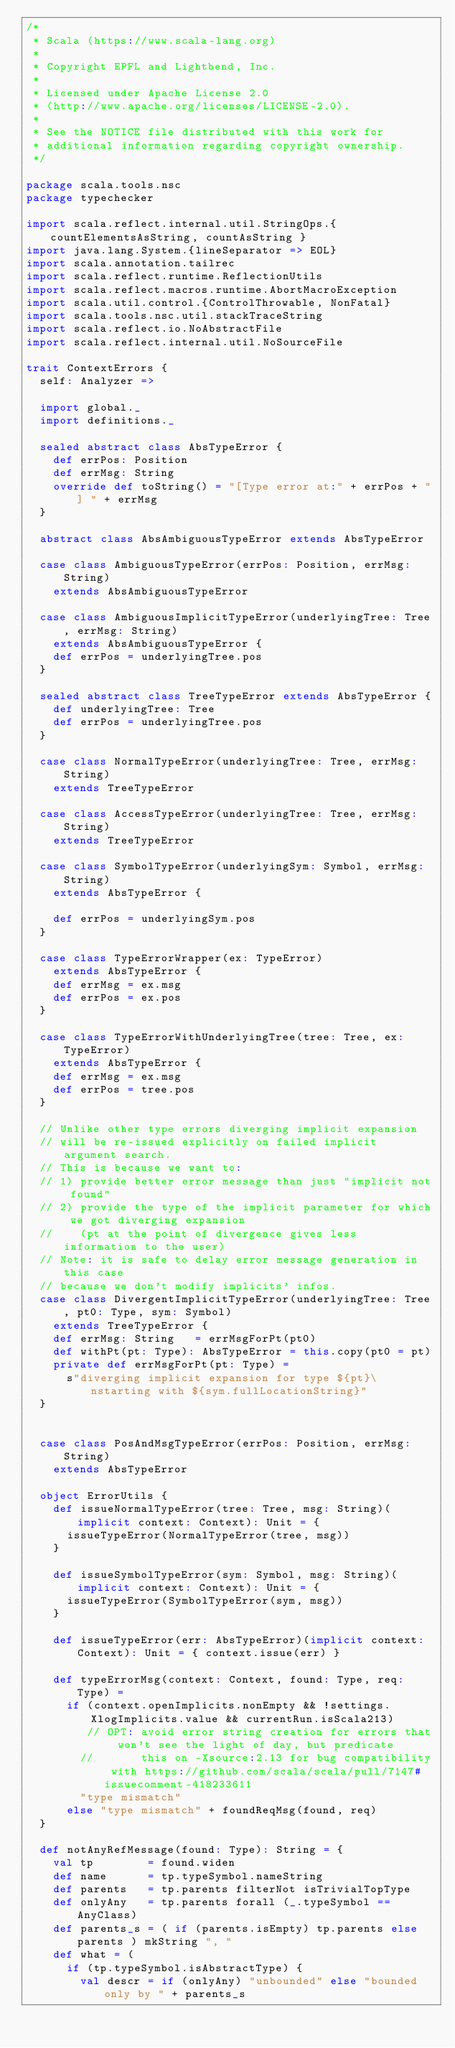<code> <loc_0><loc_0><loc_500><loc_500><_Scala_>/*
 * Scala (https://www.scala-lang.org)
 *
 * Copyright EPFL and Lightbend, Inc.
 *
 * Licensed under Apache License 2.0
 * (http://www.apache.org/licenses/LICENSE-2.0).
 *
 * See the NOTICE file distributed with this work for
 * additional information regarding copyright ownership.
 */

package scala.tools.nsc
package typechecker

import scala.reflect.internal.util.StringOps.{ countElementsAsString, countAsString }
import java.lang.System.{lineSeparator => EOL}
import scala.annotation.tailrec
import scala.reflect.runtime.ReflectionUtils
import scala.reflect.macros.runtime.AbortMacroException
import scala.util.control.{ControlThrowable, NonFatal}
import scala.tools.nsc.util.stackTraceString
import scala.reflect.io.NoAbstractFile
import scala.reflect.internal.util.NoSourceFile

trait ContextErrors {
  self: Analyzer =>

  import global._
  import definitions._

  sealed abstract class AbsTypeError {
    def errPos: Position
    def errMsg: String
    override def toString() = "[Type error at:" + errPos + "] " + errMsg
  }

  abstract class AbsAmbiguousTypeError extends AbsTypeError

  case class AmbiguousTypeError(errPos: Position, errMsg: String)
    extends AbsAmbiguousTypeError

  case class AmbiguousImplicitTypeError(underlyingTree: Tree, errMsg: String)
    extends AbsAmbiguousTypeError {
    def errPos = underlyingTree.pos
  }

  sealed abstract class TreeTypeError extends AbsTypeError {
    def underlyingTree: Tree
    def errPos = underlyingTree.pos
  }

  case class NormalTypeError(underlyingTree: Tree, errMsg: String)
    extends TreeTypeError

  case class AccessTypeError(underlyingTree: Tree, errMsg: String)
    extends TreeTypeError

  case class SymbolTypeError(underlyingSym: Symbol, errMsg: String)
    extends AbsTypeError {

    def errPos = underlyingSym.pos
  }

  case class TypeErrorWrapper(ex: TypeError)
    extends AbsTypeError {
    def errMsg = ex.msg
    def errPos = ex.pos
  }

  case class TypeErrorWithUnderlyingTree(tree: Tree, ex: TypeError)
    extends AbsTypeError {
    def errMsg = ex.msg
    def errPos = tree.pos
  }

  // Unlike other type errors diverging implicit expansion
  // will be re-issued explicitly on failed implicit argument search.
  // This is because we want to:
  // 1) provide better error message than just "implicit not found"
  // 2) provide the type of the implicit parameter for which we got diverging expansion
  //    (pt at the point of divergence gives less information to the user)
  // Note: it is safe to delay error message generation in this case
  // because we don't modify implicits' infos.
  case class DivergentImplicitTypeError(underlyingTree: Tree, pt0: Type, sym: Symbol)
    extends TreeTypeError {
    def errMsg: String   = errMsgForPt(pt0)
    def withPt(pt: Type): AbsTypeError = this.copy(pt0 = pt)
    private def errMsgForPt(pt: Type) =
      s"diverging implicit expansion for type ${pt}\nstarting with ${sym.fullLocationString}"
  }


  case class PosAndMsgTypeError(errPos: Position, errMsg: String)
    extends AbsTypeError

  object ErrorUtils {
    def issueNormalTypeError(tree: Tree, msg: String)(implicit context: Context): Unit = {
      issueTypeError(NormalTypeError(tree, msg))
    }

    def issueSymbolTypeError(sym: Symbol, msg: String)(implicit context: Context): Unit = {
      issueTypeError(SymbolTypeError(sym, msg))
    }

    def issueTypeError(err: AbsTypeError)(implicit context: Context): Unit = { context.issue(err) }

    def typeErrorMsg(context: Context, found: Type, req: Type) =
      if (context.openImplicits.nonEmpty && !settings.XlogImplicits.value && currentRun.isScala213)
         // OPT: avoid error string creation for errors that won't see the light of day, but predicate
        //       this on -Xsource:2.13 for bug compatibility with https://github.com/scala/scala/pull/7147#issuecomment-418233611
        "type mismatch"
      else "type mismatch" + foundReqMsg(found, req)
  }

  def notAnyRefMessage(found: Type): String = {
    val tp        = found.widen
    def name      = tp.typeSymbol.nameString
    def parents   = tp.parents filterNot isTrivialTopType
    def onlyAny   = tp.parents forall (_.typeSymbol == AnyClass)
    def parents_s = ( if (parents.isEmpty) tp.parents else parents ) mkString ", "
    def what = (
      if (tp.typeSymbol.isAbstractType) {
        val descr = if (onlyAny) "unbounded" else "bounded only by " + parents_s</code> 